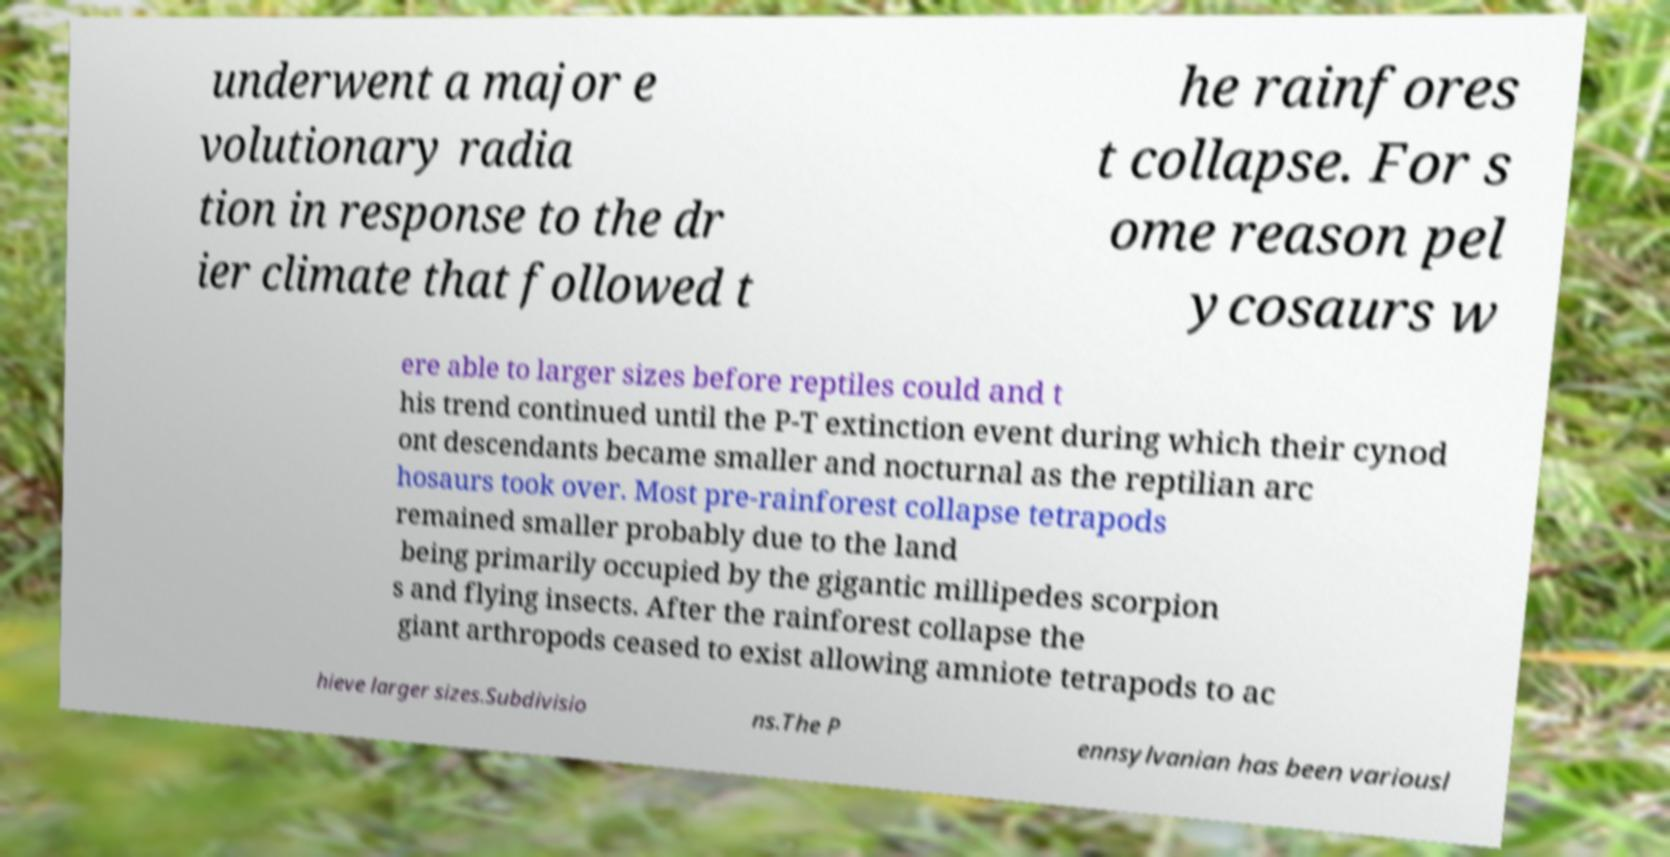I need the written content from this picture converted into text. Can you do that? underwent a major e volutionary radia tion in response to the dr ier climate that followed t he rainfores t collapse. For s ome reason pel ycosaurs w ere able to larger sizes before reptiles could and t his trend continued until the P-T extinction event during which their cynod ont descendants became smaller and nocturnal as the reptilian arc hosaurs took over. Most pre-rainforest collapse tetrapods remained smaller probably due to the land being primarily occupied by the gigantic millipedes scorpion s and flying insects. After the rainforest collapse the giant arthropods ceased to exist allowing amniote tetrapods to ac hieve larger sizes.Subdivisio ns.The P ennsylvanian has been variousl 